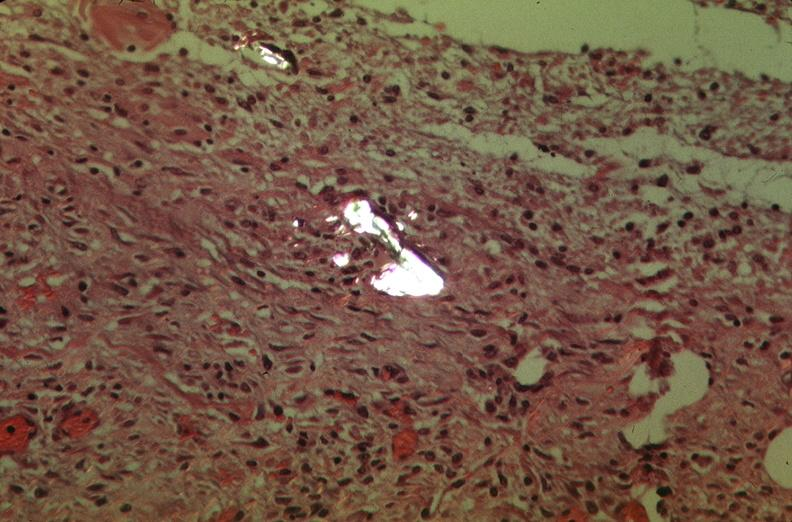what is present?
Answer the question using a single word or phrase. Respiratory 